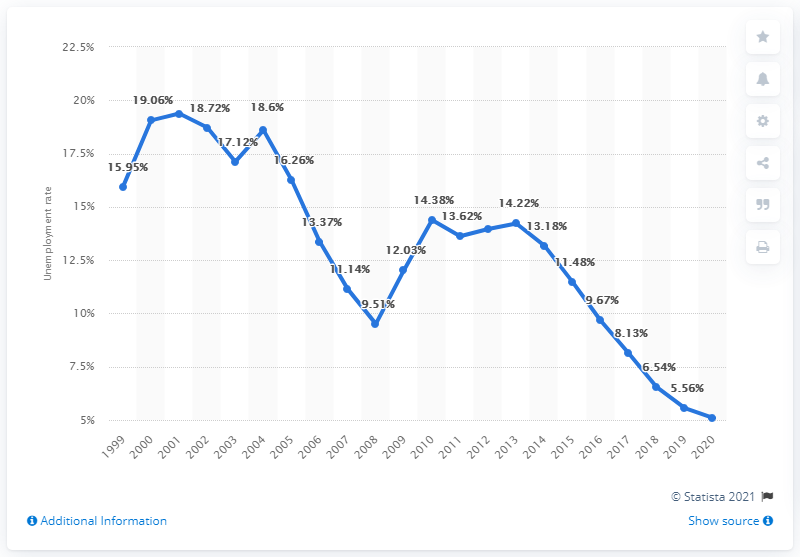Mention a couple of crucial points in this snapshot. The unemployment rate in Slovakia was 5.1% in 2020. 